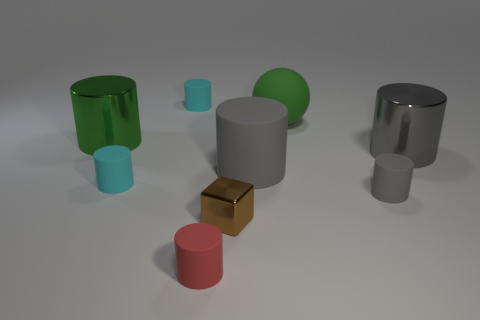Subtract all gray cylinders. How many were subtracted if there are1gray cylinders left? 2 Subtract all brown spheres. How many gray cylinders are left? 3 Subtract all green cylinders. How many cylinders are left? 6 Subtract all large metallic cylinders. How many cylinders are left? 5 Subtract all red cylinders. Subtract all green cubes. How many cylinders are left? 6 Add 1 matte cylinders. How many objects exist? 10 Subtract all cylinders. How many objects are left? 2 Add 3 small cyan cylinders. How many small cyan cylinders exist? 5 Subtract 0 blue cylinders. How many objects are left? 9 Subtract all small brown shiny cubes. Subtract all large gray shiny cylinders. How many objects are left? 7 